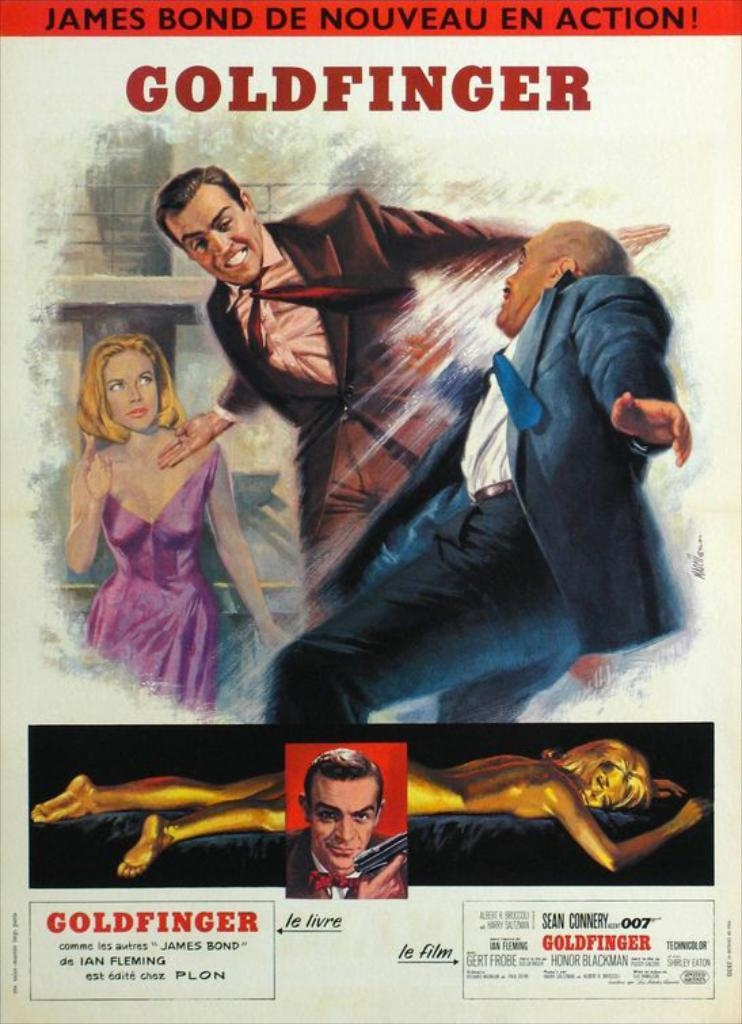<image>
Write a terse but informative summary of the picture. Movie poster of a classic film called Goldfinger 